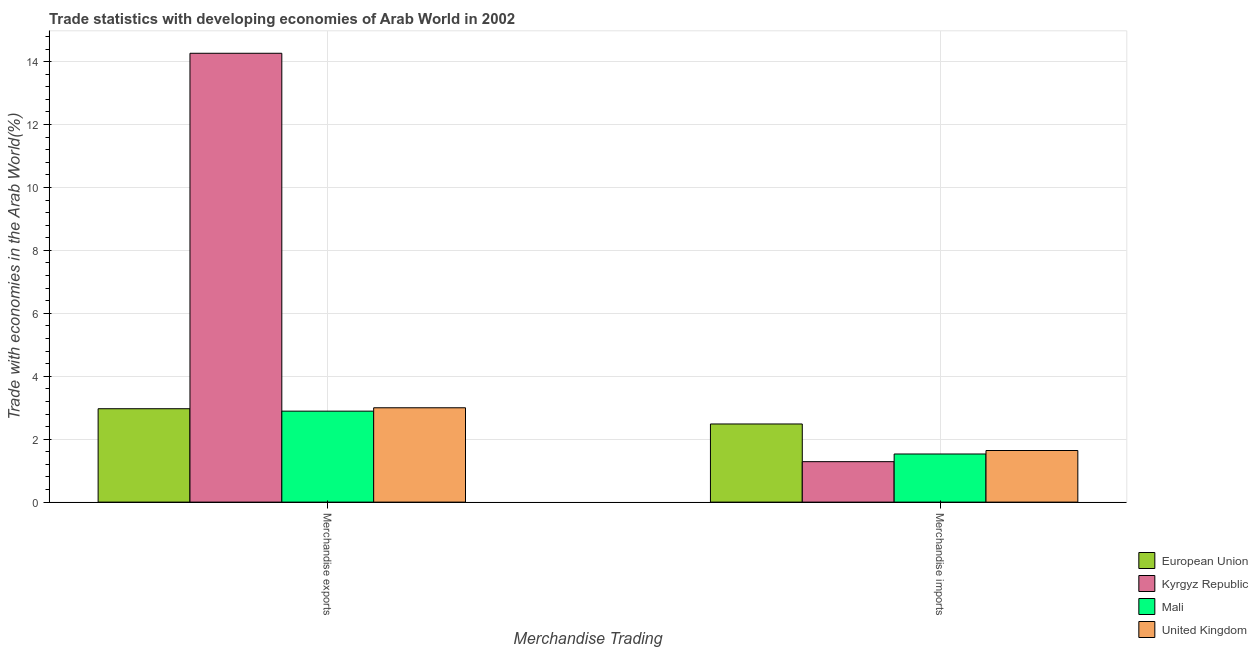How many different coloured bars are there?
Your answer should be very brief. 4. How many groups of bars are there?
Your answer should be compact. 2. What is the label of the 1st group of bars from the left?
Make the answer very short. Merchandise exports. What is the merchandise exports in Mali?
Provide a short and direct response. 2.89. Across all countries, what is the maximum merchandise imports?
Your answer should be very brief. 2.48. Across all countries, what is the minimum merchandise exports?
Ensure brevity in your answer.  2.89. In which country was the merchandise exports maximum?
Give a very brief answer. Kyrgyz Republic. In which country was the merchandise exports minimum?
Your answer should be compact. Mali. What is the total merchandise exports in the graph?
Ensure brevity in your answer.  23.12. What is the difference between the merchandise exports in European Union and that in Mali?
Provide a short and direct response. 0.08. What is the difference between the merchandise exports in Kyrgyz Republic and the merchandise imports in Mali?
Provide a succinct answer. 12.74. What is the average merchandise exports per country?
Your response must be concise. 5.78. What is the difference between the merchandise imports and merchandise exports in European Union?
Provide a succinct answer. -0.48. What is the ratio of the merchandise exports in Kyrgyz Republic to that in United Kingdom?
Your response must be concise. 4.76. Is the merchandise imports in European Union less than that in Kyrgyz Republic?
Keep it short and to the point. No. How many bars are there?
Keep it short and to the point. 8. Are all the bars in the graph horizontal?
Your answer should be compact. No. How many countries are there in the graph?
Give a very brief answer. 4. Are the values on the major ticks of Y-axis written in scientific E-notation?
Offer a very short reply. No. Where does the legend appear in the graph?
Your answer should be compact. Bottom right. How are the legend labels stacked?
Offer a terse response. Vertical. What is the title of the graph?
Make the answer very short. Trade statistics with developing economies of Arab World in 2002. Does "Liberia" appear as one of the legend labels in the graph?
Provide a succinct answer. No. What is the label or title of the X-axis?
Make the answer very short. Merchandise Trading. What is the label or title of the Y-axis?
Provide a succinct answer. Trade with economies in the Arab World(%). What is the Trade with economies in the Arab World(%) of European Union in Merchandise exports?
Your answer should be compact. 2.97. What is the Trade with economies in the Arab World(%) of Kyrgyz Republic in Merchandise exports?
Provide a short and direct response. 14.27. What is the Trade with economies in the Arab World(%) in Mali in Merchandise exports?
Your answer should be compact. 2.89. What is the Trade with economies in the Arab World(%) in United Kingdom in Merchandise exports?
Offer a terse response. 3. What is the Trade with economies in the Arab World(%) in European Union in Merchandise imports?
Provide a succinct answer. 2.48. What is the Trade with economies in the Arab World(%) of Kyrgyz Republic in Merchandise imports?
Keep it short and to the point. 1.29. What is the Trade with economies in the Arab World(%) in Mali in Merchandise imports?
Your response must be concise. 1.53. What is the Trade with economies in the Arab World(%) in United Kingdom in Merchandise imports?
Provide a short and direct response. 1.64. Across all Merchandise Trading, what is the maximum Trade with economies in the Arab World(%) of European Union?
Your answer should be very brief. 2.97. Across all Merchandise Trading, what is the maximum Trade with economies in the Arab World(%) in Kyrgyz Republic?
Provide a succinct answer. 14.27. Across all Merchandise Trading, what is the maximum Trade with economies in the Arab World(%) in Mali?
Keep it short and to the point. 2.89. Across all Merchandise Trading, what is the maximum Trade with economies in the Arab World(%) in United Kingdom?
Keep it short and to the point. 3. Across all Merchandise Trading, what is the minimum Trade with economies in the Arab World(%) in European Union?
Your answer should be compact. 2.48. Across all Merchandise Trading, what is the minimum Trade with economies in the Arab World(%) in Kyrgyz Republic?
Make the answer very short. 1.29. Across all Merchandise Trading, what is the minimum Trade with economies in the Arab World(%) of Mali?
Provide a short and direct response. 1.53. Across all Merchandise Trading, what is the minimum Trade with economies in the Arab World(%) in United Kingdom?
Offer a very short reply. 1.64. What is the total Trade with economies in the Arab World(%) of European Union in the graph?
Offer a terse response. 5.45. What is the total Trade with economies in the Arab World(%) of Kyrgyz Republic in the graph?
Give a very brief answer. 15.55. What is the total Trade with economies in the Arab World(%) of Mali in the graph?
Your answer should be compact. 4.42. What is the total Trade with economies in the Arab World(%) of United Kingdom in the graph?
Offer a very short reply. 4.64. What is the difference between the Trade with economies in the Arab World(%) of European Union in Merchandise exports and that in Merchandise imports?
Ensure brevity in your answer.  0.48. What is the difference between the Trade with economies in the Arab World(%) of Kyrgyz Republic in Merchandise exports and that in Merchandise imports?
Your answer should be compact. 12.98. What is the difference between the Trade with economies in the Arab World(%) in Mali in Merchandise exports and that in Merchandise imports?
Make the answer very short. 1.36. What is the difference between the Trade with economies in the Arab World(%) in United Kingdom in Merchandise exports and that in Merchandise imports?
Provide a short and direct response. 1.36. What is the difference between the Trade with economies in the Arab World(%) in European Union in Merchandise exports and the Trade with economies in the Arab World(%) in Kyrgyz Republic in Merchandise imports?
Make the answer very short. 1.68. What is the difference between the Trade with economies in the Arab World(%) of European Union in Merchandise exports and the Trade with economies in the Arab World(%) of Mali in Merchandise imports?
Your response must be concise. 1.44. What is the difference between the Trade with economies in the Arab World(%) in European Union in Merchandise exports and the Trade with economies in the Arab World(%) in United Kingdom in Merchandise imports?
Ensure brevity in your answer.  1.33. What is the difference between the Trade with economies in the Arab World(%) in Kyrgyz Republic in Merchandise exports and the Trade with economies in the Arab World(%) in Mali in Merchandise imports?
Ensure brevity in your answer.  12.74. What is the difference between the Trade with economies in the Arab World(%) of Kyrgyz Republic in Merchandise exports and the Trade with economies in the Arab World(%) of United Kingdom in Merchandise imports?
Your answer should be very brief. 12.62. What is the difference between the Trade with economies in the Arab World(%) in Mali in Merchandise exports and the Trade with economies in the Arab World(%) in United Kingdom in Merchandise imports?
Provide a short and direct response. 1.25. What is the average Trade with economies in the Arab World(%) of European Union per Merchandise Trading?
Offer a terse response. 2.73. What is the average Trade with economies in the Arab World(%) in Kyrgyz Republic per Merchandise Trading?
Give a very brief answer. 7.78. What is the average Trade with economies in the Arab World(%) in Mali per Merchandise Trading?
Provide a short and direct response. 2.21. What is the average Trade with economies in the Arab World(%) in United Kingdom per Merchandise Trading?
Make the answer very short. 2.32. What is the difference between the Trade with economies in the Arab World(%) in European Union and Trade with economies in the Arab World(%) in Kyrgyz Republic in Merchandise exports?
Your response must be concise. -11.3. What is the difference between the Trade with economies in the Arab World(%) of European Union and Trade with economies in the Arab World(%) of Mali in Merchandise exports?
Provide a short and direct response. 0.08. What is the difference between the Trade with economies in the Arab World(%) in European Union and Trade with economies in the Arab World(%) in United Kingdom in Merchandise exports?
Give a very brief answer. -0.03. What is the difference between the Trade with economies in the Arab World(%) in Kyrgyz Republic and Trade with economies in the Arab World(%) in Mali in Merchandise exports?
Your answer should be compact. 11.37. What is the difference between the Trade with economies in the Arab World(%) of Kyrgyz Republic and Trade with economies in the Arab World(%) of United Kingdom in Merchandise exports?
Keep it short and to the point. 11.27. What is the difference between the Trade with economies in the Arab World(%) of Mali and Trade with economies in the Arab World(%) of United Kingdom in Merchandise exports?
Provide a short and direct response. -0.11. What is the difference between the Trade with economies in the Arab World(%) in European Union and Trade with economies in the Arab World(%) in Kyrgyz Republic in Merchandise imports?
Provide a short and direct response. 1.2. What is the difference between the Trade with economies in the Arab World(%) in European Union and Trade with economies in the Arab World(%) in Mali in Merchandise imports?
Provide a succinct answer. 0.95. What is the difference between the Trade with economies in the Arab World(%) of European Union and Trade with economies in the Arab World(%) of United Kingdom in Merchandise imports?
Offer a very short reply. 0.84. What is the difference between the Trade with economies in the Arab World(%) of Kyrgyz Republic and Trade with economies in the Arab World(%) of Mali in Merchandise imports?
Make the answer very short. -0.24. What is the difference between the Trade with economies in the Arab World(%) in Kyrgyz Republic and Trade with economies in the Arab World(%) in United Kingdom in Merchandise imports?
Make the answer very short. -0.35. What is the difference between the Trade with economies in the Arab World(%) in Mali and Trade with economies in the Arab World(%) in United Kingdom in Merchandise imports?
Offer a very short reply. -0.11. What is the ratio of the Trade with economies in the Arab World(%) in European Union in Merchandise exports to that in Merchandise imports?
Keep it short and to the point. 1.2. What is the ratio of the Trade with economies in the Arab World(%) of Kyrgyz Republic in Merchandise exports to that in Merchandise imports?
Provide a succinct answer. 11.09. What is the ratio of the Trade with economies in the Arab World(%) of Mali in Merchandise exports to that in Merchandise imports?
Your response must be concise. 1.89. What is the ratio of the Trade with economies in the Arab World(%) in United Kingdom in Merchandise exports to that in Merchandise imports?
Offer a very short reply. 1.83. What is the difference between the highest and the second highest Trade with economies in the Arab World(%) of European Union?
Your answer should be very brief. 0.48. What is the difference between the highest and the second highest Trade with economies in the Arab World(%) in Kyrgyz Republic?
Your answer should be compact. 12.98. What is the difference between the highest and the second highest Trade with economies in the Arab World(%) of Mali?
Offer a terse response. 1.36. What is the difference between the highest and the second highest Trade with economies in the Arab World(%) of United Kingdom?
Your response must be concise. 1.36. What is the difference between the highest and the lowest Trade with economies in the Arab World(%) of European Union?
Offer a terse response. 0.48. What is the difference between the highest and the lowest Trade with economies in the Arab World(%) of Kyrgyz Republic?
Ensure brevity in your answer.  12.98. What is the difference between the highest and the lowest Trade with economies in the Arab World(%) of Mali?
Your answer should be very brief. 1.36. What is the difference between the highest and the lowest Trade with economies in the Arab World(%) in United Kingdom?
Provide a short and direct response. 1.36. 